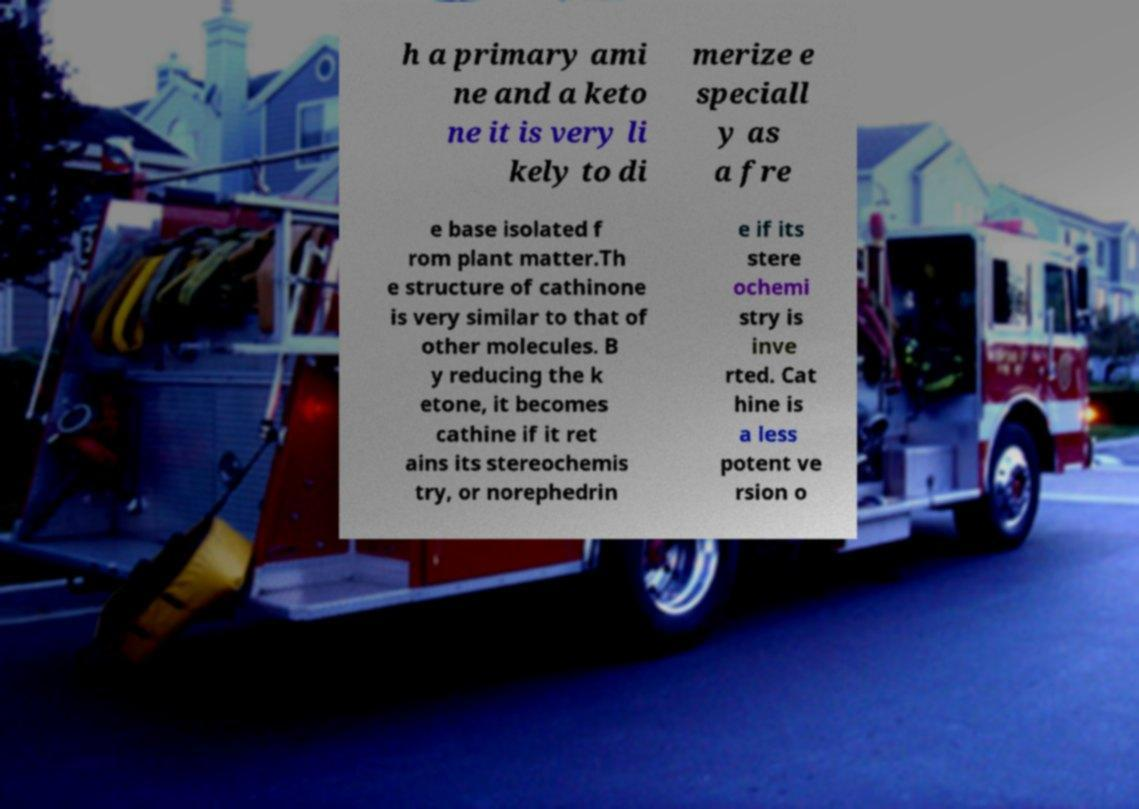For documentation purposes, I need the text within this image transcribed. Could you provide that? h a primary ami ne and a keto ne it is very li kely to di merize e speciall y as a fre e base isolated f rom plant matter.Th e structure of cathinone is very similar to that of other molecules. B y reducing the k etone, it becomes cathine if it ret ains its stereochemis try, or norephedrin e if its stere ochemi stry is inve rted. Cat hine is a less potent ve rsion o 